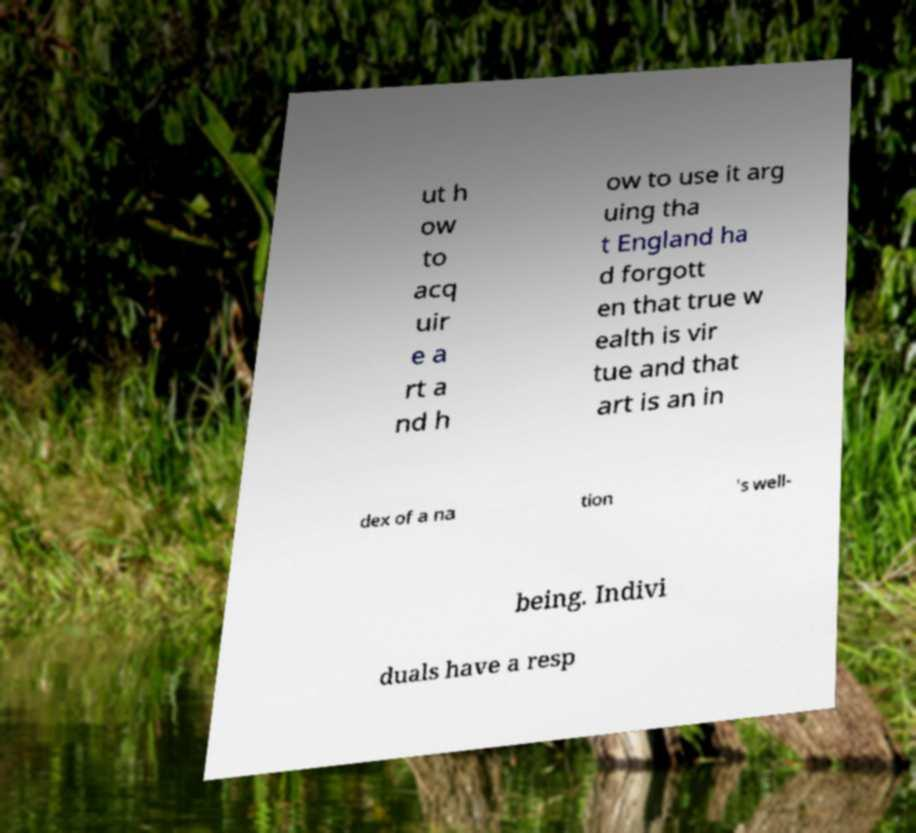For documentation purposes, I need the text within this image transcribed. Could you provide that? ut h ow to acq uir e a rt a nd h ow to use it arg uing tha t England ha d forgott en that true w ealth is vir tue and that art is an in dex of a na tion 's well- being. Indivi duals have a resp 